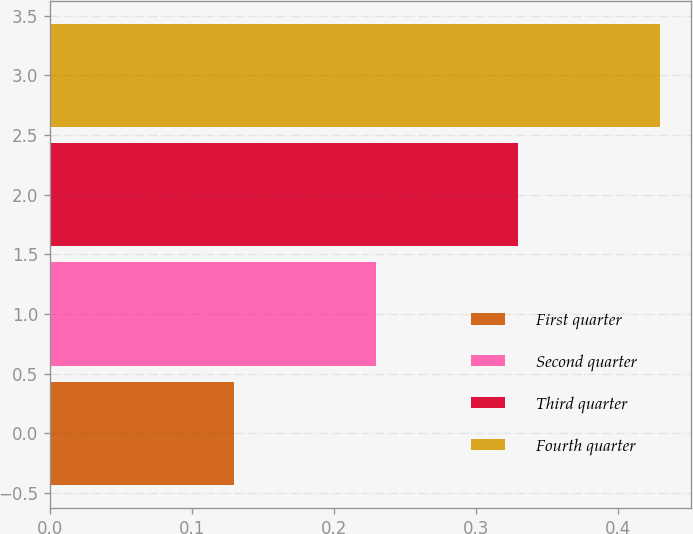<chart> <loc_0><loc_0><loc_500><loc_500><bar_chart><fcel>First quarter<fcel>Second quarter<fcel>Third quarter<fcel>Fourth quarter<nl><fcel>0.13<fcel>0.23<fcel>0.33<fcel>0.43<nl></chart> 